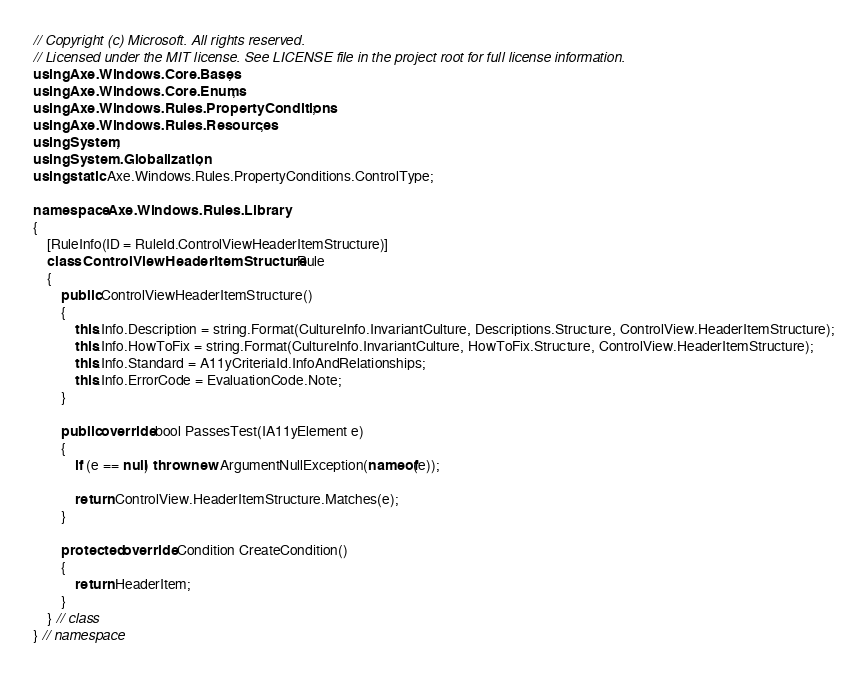<code> <loc_0><loc_0><loc_500><loc_500><_C#_>// Copyright (c) Microsoft. All rights reserved.
// Licensed under the MIT license. See LICENSE file in the project root for full license information.
using Axe.Windows.Core.Bases;
using Axe.Windows.Core.Enums;
using Axe.Windows.Rules.PropertyConditions;
using Axe.Windows.Rules.Resources;
using System;
using System.Globalization;
using static Axe.Windows.Rules.PropertyConditions.ControlType;

namespace Axe.Windows.Rules.Library
{
    [RuleInfo(ID = RuleId.ControlViewHeaderItemStructure)]
    class ControlViewHeaderItemStructure : Rule
    {
        public ControlViewHeaderItemStructure()
        {
            this.Info.Description = string.Format(CultureInfo.InvariantCulture, Descriptions.Structure, ControlView.HeaderItemStructure);
            this.Info.HowToFix = string.Format(CultureInfo.InvariantCulture, HowToFix.Structure, ControlView.HeaderItemStructure);
            this.Info.Standard = A11yCriteriaId.InfoAndRelationships;
            this.Info.ErrorCode = EvaluationCode.Note;
        }

        public override bool PassesTest(IA11yElement e)
        {
            if (e == null) throw new ArgumentNullException(nameof(e));

            return ControlView.HeaderItemStructure.Matches(e);
        }

        protected override Condition CreateCondition()
        {
            return HeaderItem;
        }
    } // class
} // namespace
</code> 